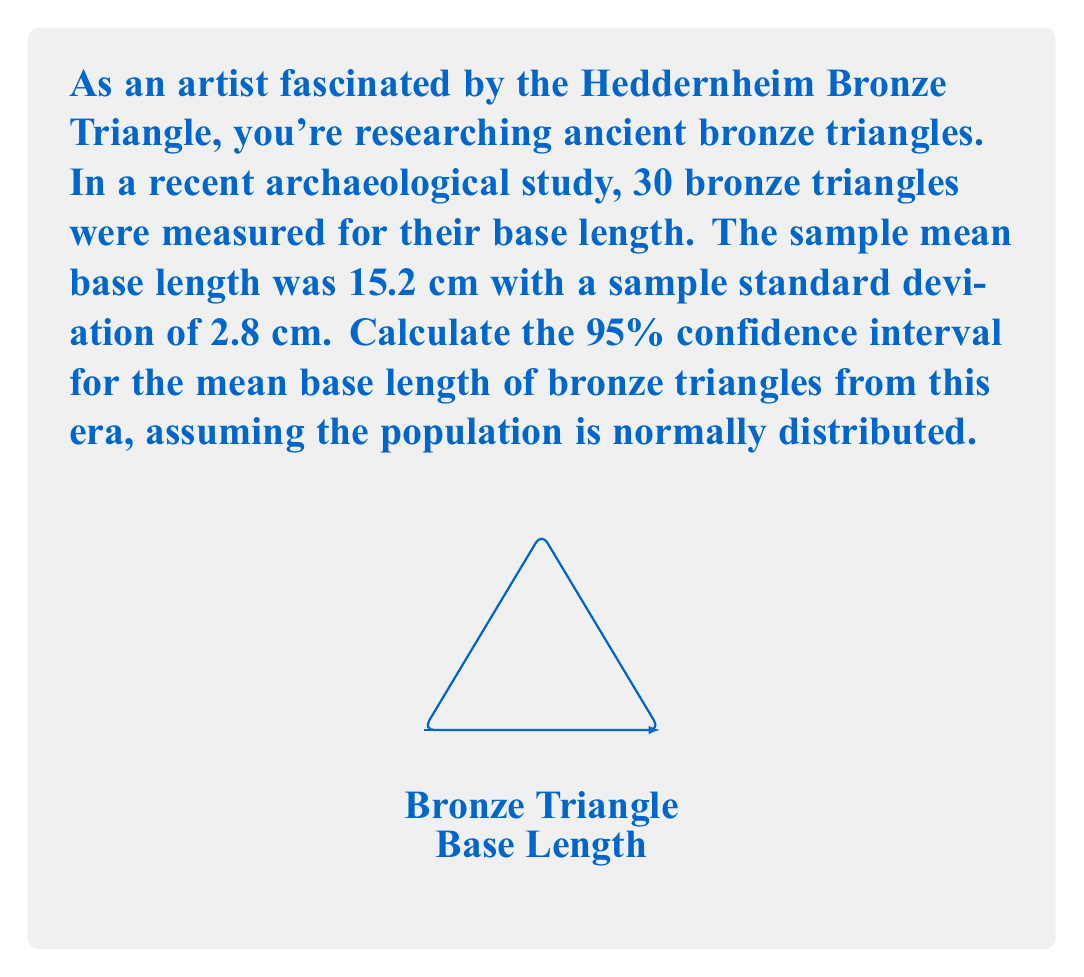Provide a solution to this math problem. To calculate the confidence interval, we'll use the formula:

$$ \text{CI} = \bar{x} \pm t_{\frac{\alpha}{2}, n-1} \cdot \frac{s}{\sqrt{n}} $$

Where:
- $\bar{x}$ is the sample mean (15.2 cm)
- $s$ is the sample standard deviation (2.8 cm)
- $n$ is the sample size (30)
- $t_{\frac{\alpha}{2}, n-1}$ is the t-value for a 95% confidence interval with 29 degrees of freedom

Steps:
1) Find $t_{\frac{\alpha}{2}, n-1}$:
   For a 95% CI with 29 df, $t_{0.025, 29} \approx 2.045$

2) Calculate the margin of error:
   $$ \text{ME} = t_{\frac{\alpha}{2}, n-1} \cdot \frac{s}{\sqrt{n}} = 2.045 \cdot \frac{2.8}{\sqrt{30}} \approx 1.05 $$

3) Calculate the confidence interval:
   $$ \text{CI} = 15.2 \pm 1.05 $$
   $$ \text{CI} = (14.15, 16.25) $$

Therefore, we can be 95% confident that the true population mean base length of bronze triangles from this era is between 14.15 cm and 16.25 cm.
Answer: (14.15 cm, 16.25 cm) 